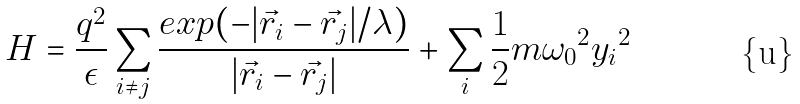Convert formula to latex. <formula><loc_0><loc_0><loc_500><loc_500>H = \frac { q ^ { 2 } } { \epsilon } \sum _ { i \neq j } \frac { e x p ( - | \vec { r _ { i } } - \vec { r _ { j } } | / \lambda ) } { | \vec { r _ { i } } - \vec { r _ { j } } | } + \sum _ { i } \frac { 1 } { 2 } m { \omega _ { 0 } } ^ { 2 } { y _ { i } } ^ { 2 }</formula> 